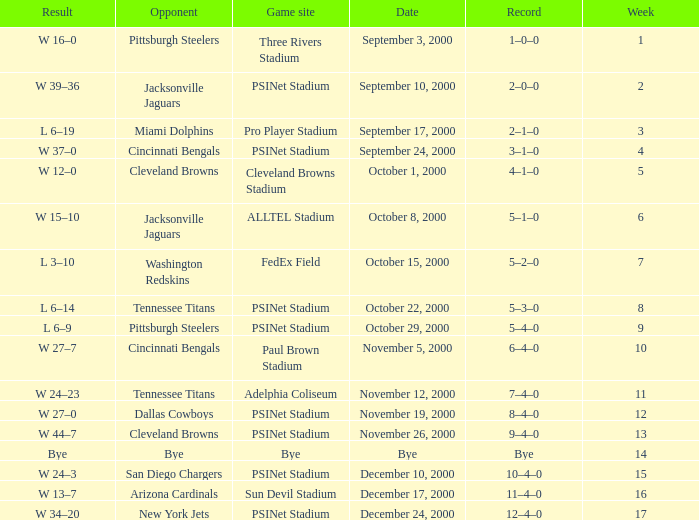What's the record for October 8, 2000 before week 13? 5–1–0. 